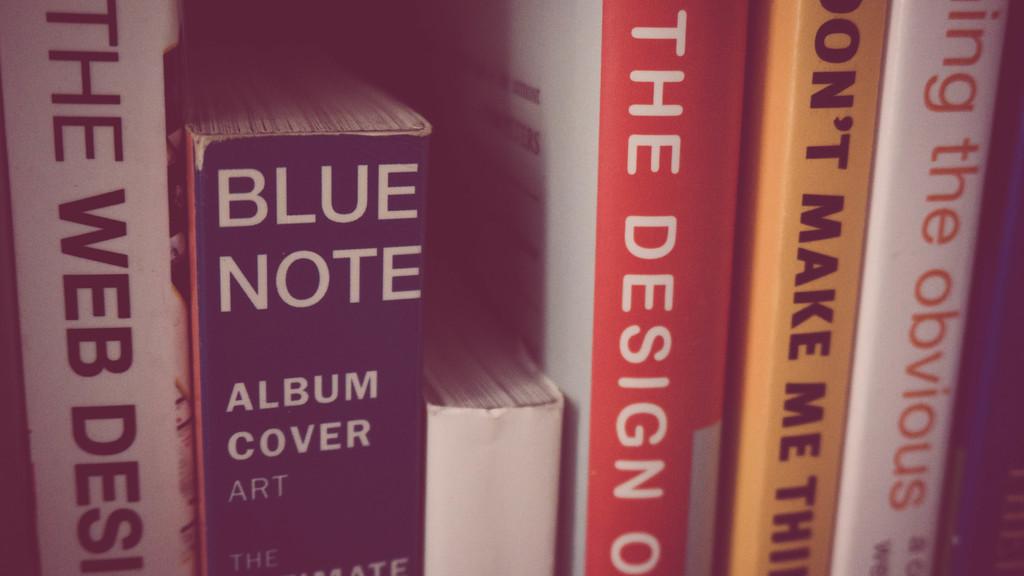What kind of cover art does the book blue note contain?
Provide a succinct answer. Album cover art. What is the title of the book with a red spine?
Your answer should be very brief. The design. 